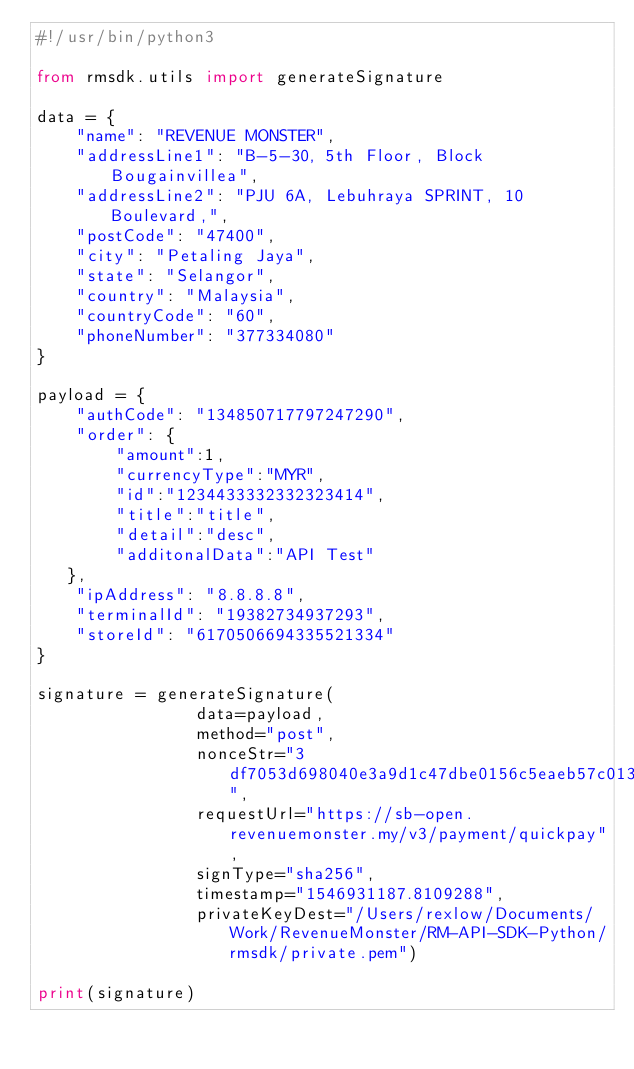<code> <loc_0><loc_0><loc_500><loc_500><_Python_>#!/usr/bin/python3

from rmsdk.utils import generateSignature

data = {
    "name": "REVENUE MONSTER",
    "addressLine1": "B-5-30, 5th Floor, Block Bougainvillea",
    "addressLine2": "PJU 6A, Lebuhraya SPRINT, 10 Boulevard,",
    "postCode": "47400",
    "city": "Petaling Jaya",
    "state": "Selangor",
    "country": "Malaysia",
    "countryCode": "60",
    "phoneNumber": "377334080"
}

payload = {
    "authCode": "134850717797247290",
    "order": {
        "amount":1,
        "currencyType":"MYR",
        "id":"1234433332332323414",
        "title":"title",
        "detail":"desc",
        "additonalData":"API Test"
   },
    "ipAddress": "8.8.8.8",
    "terminalId": "19382734937293",
    "storeId": "6170506694335521334"
}

signature = generateSignature(
                data=payload, 
                method="post", 
                nonceStr="3df7053d698040e3a9d1c47dbe0156c5eaeb57c0131311e9915ea860b635ee61", 
                requestUrl="https://sb-open.revenuemonster.my/v3/payment/quickpay", 
                signType="sha256", 
                timestamp="1546931187.8109288", 
                privateKeyDest="/Users/rexlow/Documents/Work/RevenueMonster/RM-API-SDK-Python/rmsdk/private.pem")

print(signature)</code> 